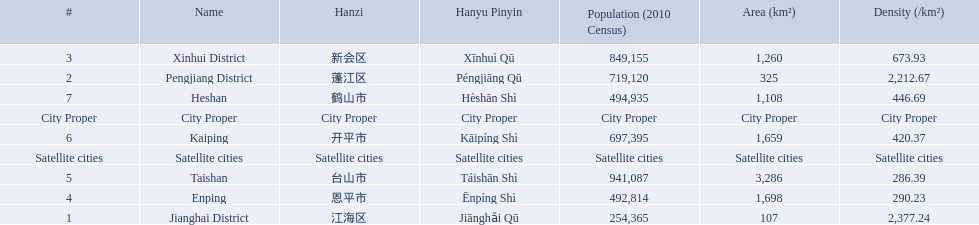What are all of the city proper district names? Jianghai District, Pengjiang District, Xinhui District. Of those districts, what are is the value for their area (km2)? 107, 325, 1,260. Of those area values, which district does the smallest value belong to? Jianghai District. 